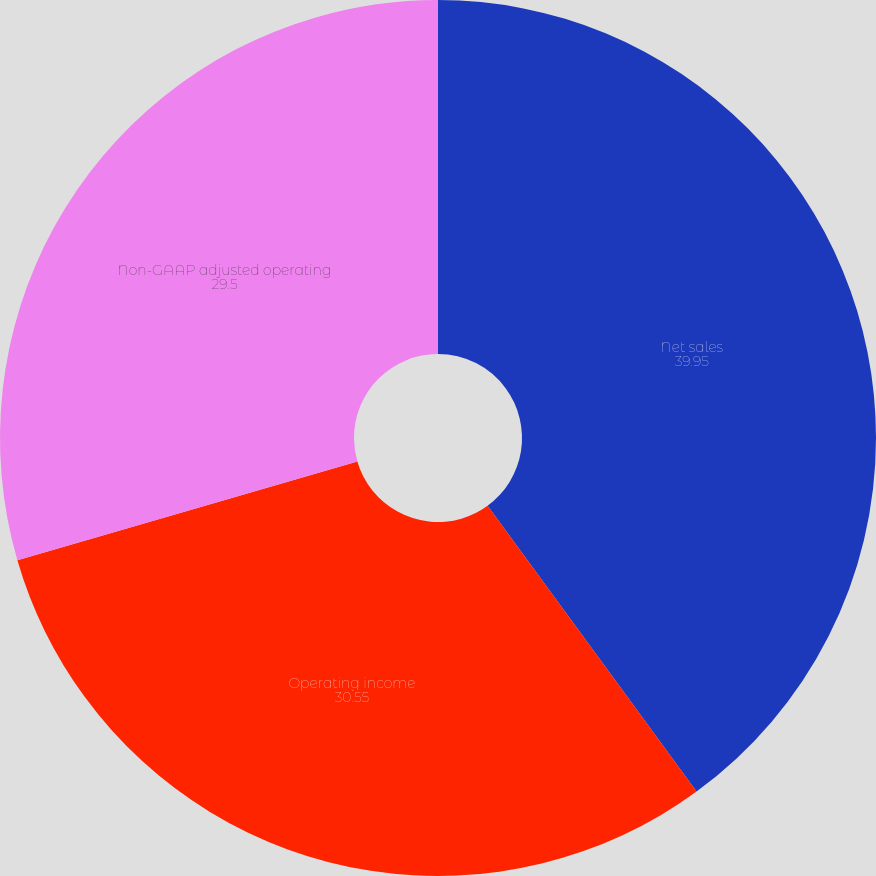Convert chart. <chart><loc_0><loc_0><loc_500><loc_500><pie_chart><fcel>Net sales<fcel>Operating income<fcel>Non-GAAP adjusted operating<nl><fcel>39.95%<fcel>30.55%<fcel>29.5%<nl></chart> 